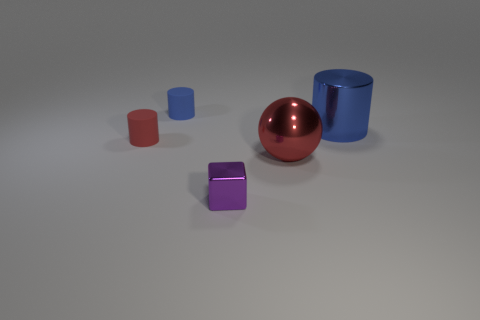What are the different materials or finishes that the objects seem to have? The objects appear to have different finishes: the sphere and one cylinder have a reflective glossy finish, the blue cylinder has a matte finish, and the cubes have a slightly textured appearance. 